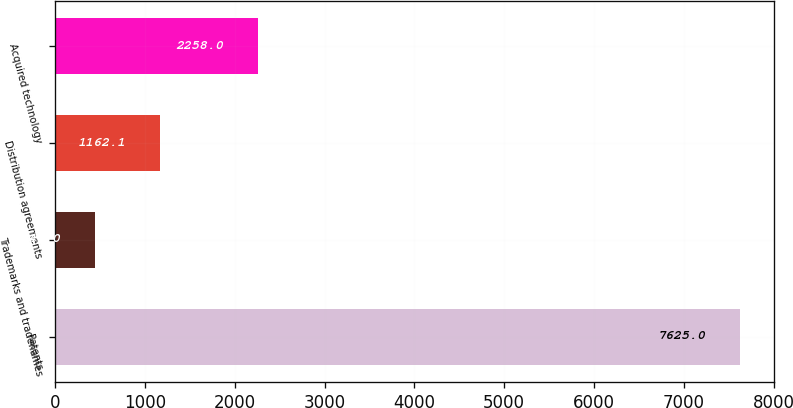<chart> <loc_0><loc_0><loc_500><loc_500><bar_chart><fcel>Patents<fcel>Trademarks and tradenames<fcel>Distribution agreements<fcel>Acquired technology<nl><fcel>7625<fcel>444<fcel>1162.1<fcel>2258<nl></chart> 